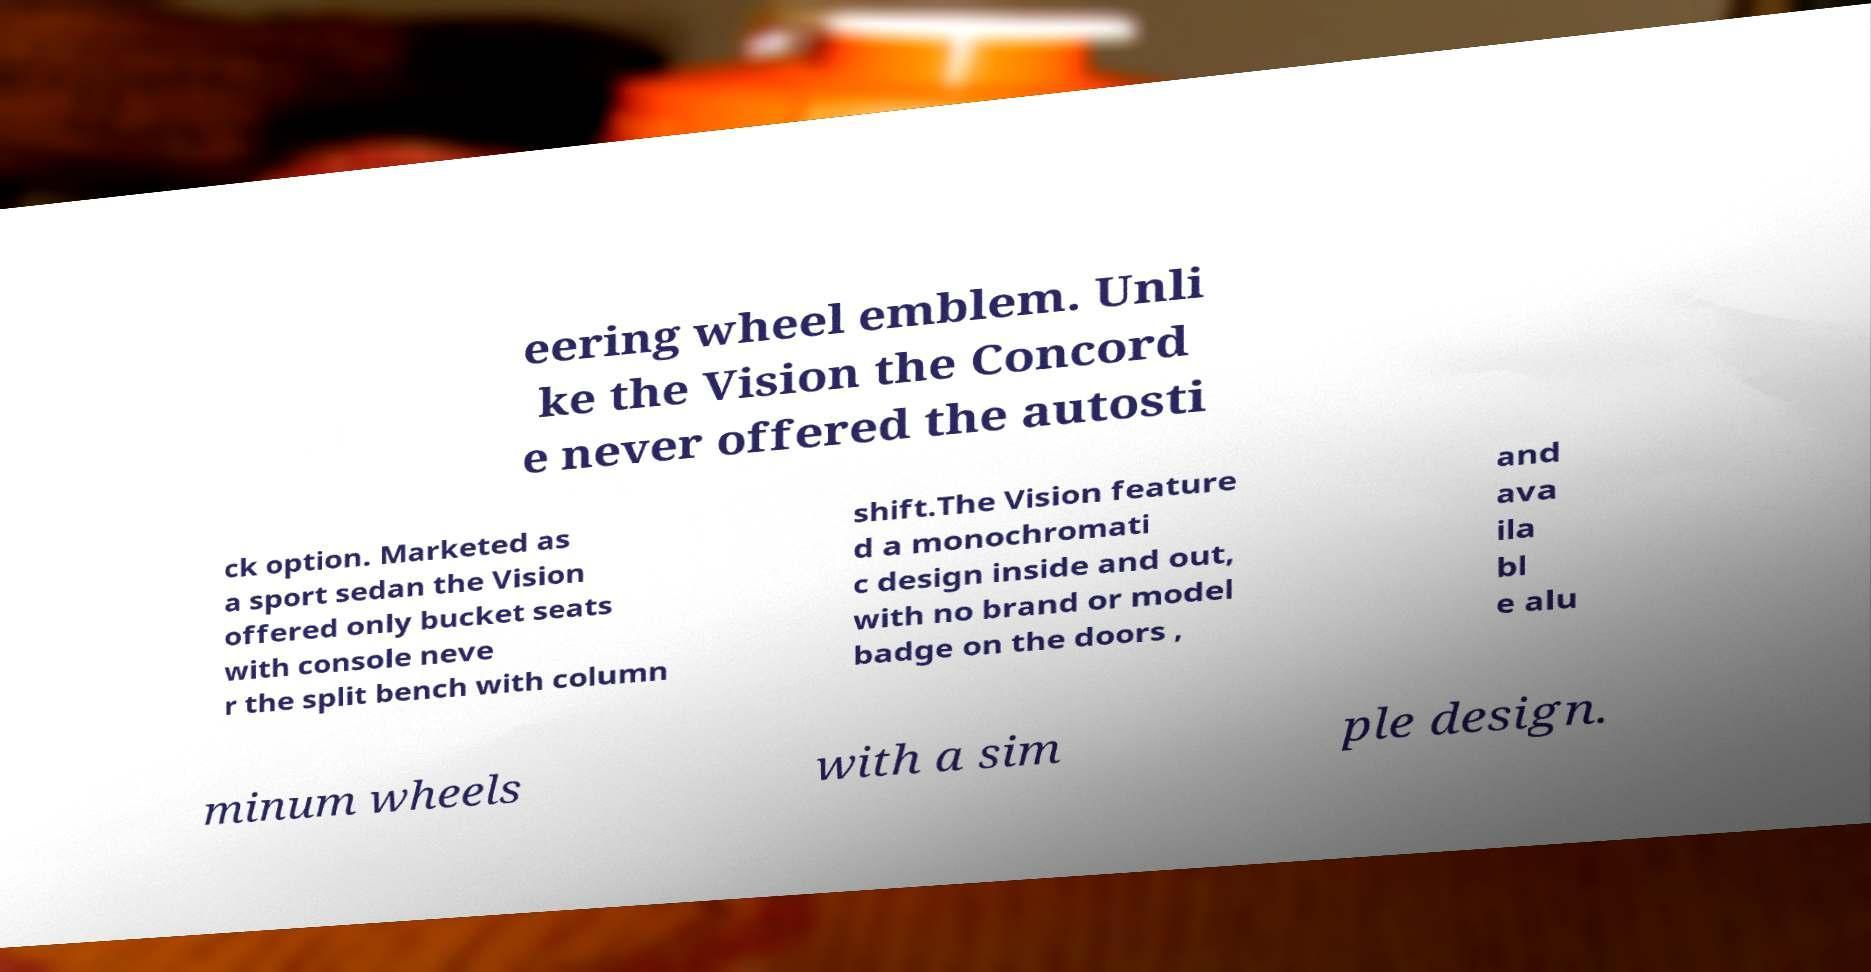Please identify and transcribe the text found in this image. eering wheel emblem. Unli ke the Vision the Concord e never offered the autosti ck option. Marketed as a sport sedan the Vision offered only bucket seats with console neve r the split bench with column shift.The Vision feature d a monochromati c design inside and out, with no brand or model badge on the doors , and ava ila bl e alu minum wheels with a sim ple design. 